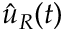<formula> <loc_0><loc_0><loc_500><loc_500>{ \hat { u } } _ { R } ( t )</formula> 